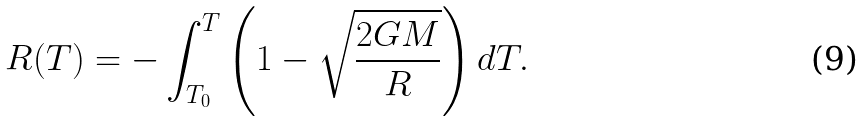Convert formula to latex. <formula><loc_0><loc_0><loc_500><loc_500>R ( T ) = - \int _ { T _ { 0 } } ^ { T } \left ( 1 - \sqrt { \frac { 2 G M } { R } } \right ) d T .</formula> 